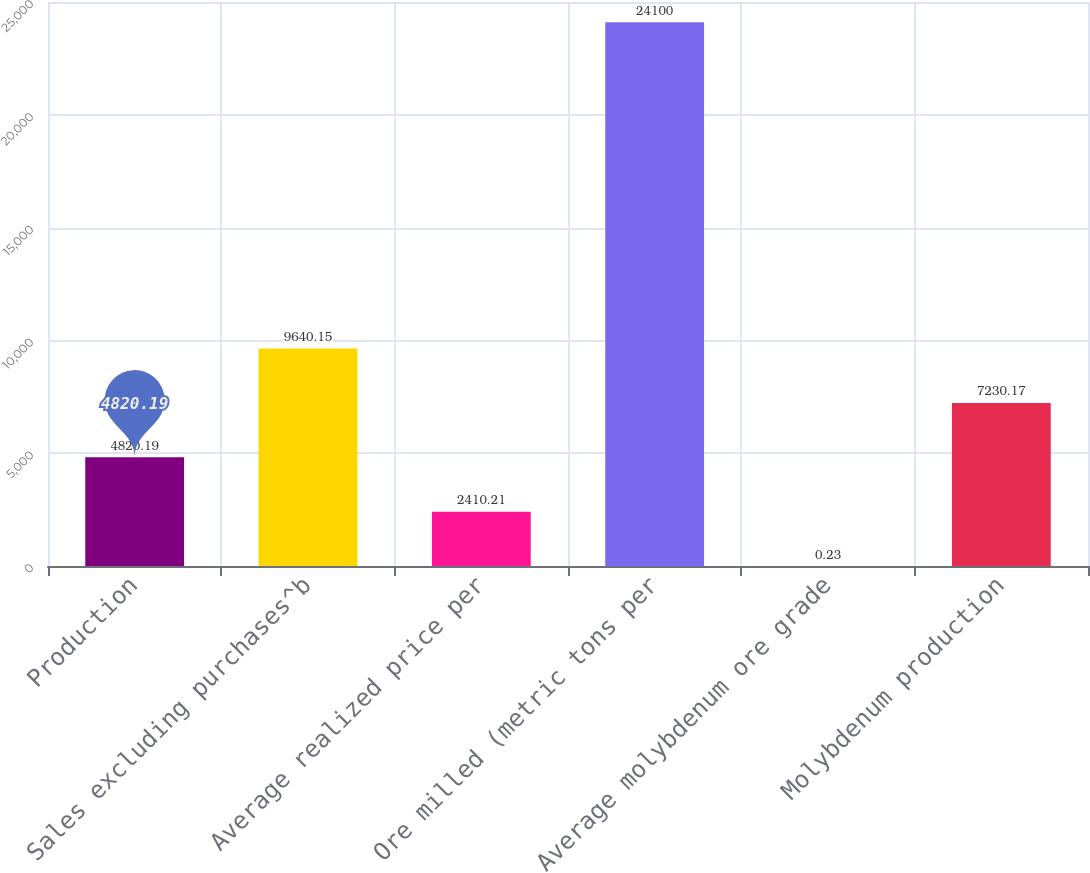Convert chart to OTSL. <chart><loc_0><loc_0><loc_500><loc_500><bar_chart><fcel>Production<fcel>Sales excluding purchases^b<fcel>Average realized price per<fcel>Ore milled (metric tons per<fcel>Average molybdenum ore grade<fcel>Molybdenum production<nl><fcel>4820.19<fcel>9640.15<fcel>2410.21<fcel>24100<fcel>0.23<fcel>7230.17<nl></chart> 